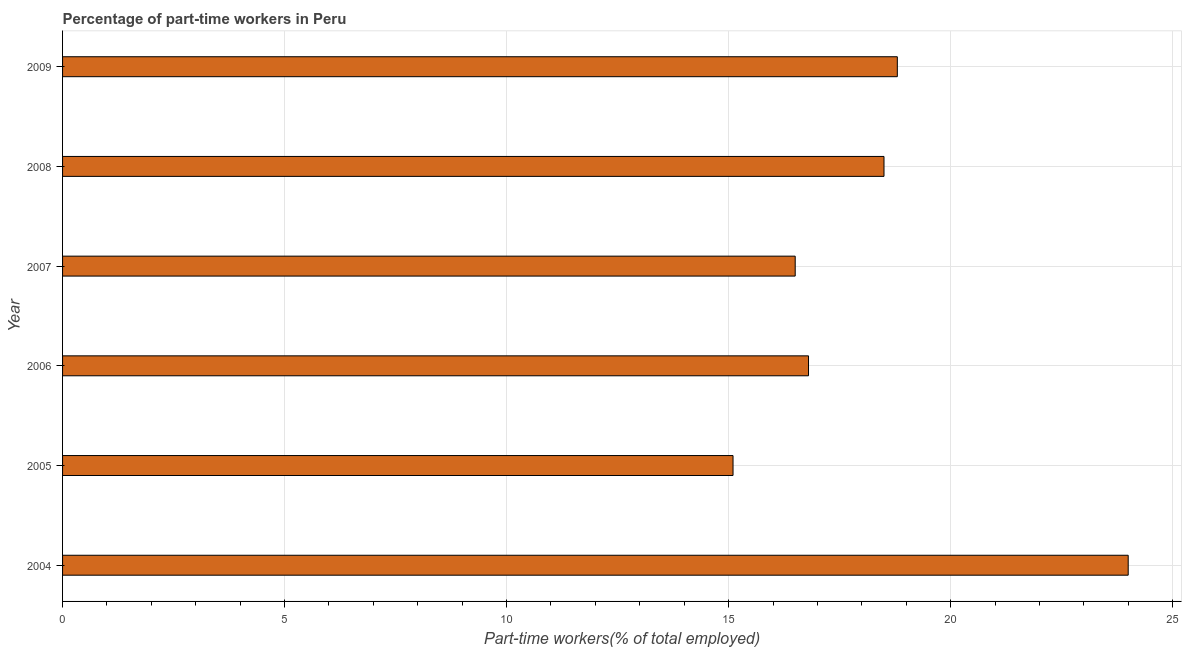What is the title of the graph?
Make the answer very short. Percentage of part-time workers in Peru. What is the label or title of the X-axis?
Ensure brevity in your answer.  Part-time workers(% of total employed). What is the percentage of part-time workers in 2007?
Keep it short and to the point. 16.5. Across all years, what is the maximum percentage of part-time workers?
Make the answer very short. 24. Across all years, what is the minimum percentage of part-time workers?
Keep it short and to the point. 15.1. In which year was the percentage of part-time workers maximum?
Ensure brevity in your answer.  2004. In which year was the percentage of part-time workers minimum?
Ensure brevity in your answer.  2005. What is the sum of the percentage of part-time workers?
Provide a short and direct response. 109.7. What is the difference between the percentage of part-time workers in 2006 and 2008?
Your response must be concise. -1.7. What is the average percentage of part-time workers per year?
Your answer should be very brief. 18.28. What is the median percentage of part-time workers?
Your answer should be very brief. 17.65. In how many years, is the percentage of part-time workers greater than 7 %?
Offer a terse response. 6. What is the ratio of the percentage of part-time workers in 2004 to that in 2006?
Your answer should be very brief. 1.43. Is the difference between the percentage of part-time workers in 2004 and 2009 greater than the difference between any two years?
Ensure brevity in your answer.  No. Is the sum of the percentage of part-time workers in 2004 and 2008 greater than the maximum percentage of part-time workers across all years?
Provide a short and direct response. Yes. What is the difference between the highest and the lowest percentage of part-time workers?
Make the answer very short. 8.9. Are all the bars in the graph horizontal?
Provide a succinct answer. Yes. What is the difference between two consecutive major ticks on the X-axis?
Your answer should be very brief. 5. Are the values on the major ticks of X-axis written in scientific E-notation?
Your answer should be very brief. No. What is the Part-time workers(% of total employed) of 2004?
Provide a succinct answer. 24. What is the Part-time workers(% of total employed) in 2005?
Your answer should be very brief. 15.1. What is the Part-time workers(% of total employed) in 2006?
Make the answer very short. 16.8. What is the Part-time workers(% of total employed) of 2007?
Your answer should be very brief. 16.5. What is the Part-time workers(% of total employed) of 2008?
Make the answer very short. 18.5. What is the Part-time workers(% of total employed) in 2009?
Offer a very short reply. 18.8. What is the difference between the Part-time workers(% of total employed) in 2004 and 2006?
Provide a short and direct response. 7.2. What is the difference between the Part-time workers(% of total employed) in 2004 and 2009?
Give a very brief answer. 5.2. What is the difference between the Part-time workers(% of total employed) in 2005 and 2006?
Keep it short and to the point. -1.7. What is the difference between the Part-time workers(% of total employed) in 2005 and 2009?
Ensure brevity in your answer.  -3.7. What is the difference between the Part-time workers(% of total employed) in 2006 and 2007?
Your answer should be compact. 0.3. What is the difference between the Part-time workers(% of total employed) in 2006 and 2008?
Offer a terse response. -1.7. What is the difference between the Part-time workers(% of total employed) in 2007 and 2008?
Give a very brief answer. -2. What is the ratio of the Part-time workers(% of total employed) in 2004 to that in 2005?
Your answer should be very brief. 1.59. What is the ratio of the Part-time workers(% of total employed) in 2004 to that in 2006?
Provide a short and direct response. 1.43. What is the ratio of the Part-time workers(% of total employed) in 2004 to that in 2007?
Give a very brief answer. 1.46. What is the ratio of the Part-time workers(% of total employed) in 2004 to that in 2008?
Keep it short and to the point. 1.3. What is the ratio of the Part-time workers(% of total employed) in 2004 to that in 2009?
Give a very brief answer. 1.28. What is the ratio of the Part-time workers(% of total employed) in 2005 to that in 2006?
Make the answer very short. 0.9. What is the ratio of the Part-time workers(% of total employed) in 2005 to that in 2007?
Give a very brief answer. 0.92. What is the ratio of the Part-time workers(% of total employed) in 2005 to that in 2008?
Your answer should be very brief. 0.82. What is the ratio of the Part-time workers(% of total employed) in 2005 to that in 2009?
Give a very brief answer. 0.8. What is the ratio of the Part-time workers(% of total employed) in 2006 to that in 2008?
Offer a terse response. 0.91. What is the ratio of the Part-time workers(% of total employed) in 2006 to that in 2009?
Ensure brevity in your answer.  0.89. What is the ratio of the Part-time workers(% of total employed) in 2007 to that in 2008?
Offer a terse response. 0.89. What is the ratio of the Part-time workers(% of total employed) in 2007 to that in 2009?
Provide a short and direct response. 0.88. What is the ratio of the Part-time workers(% of total employed) in 2008 to that in 2009?
Ensure brevity in your answer.  0.98. 